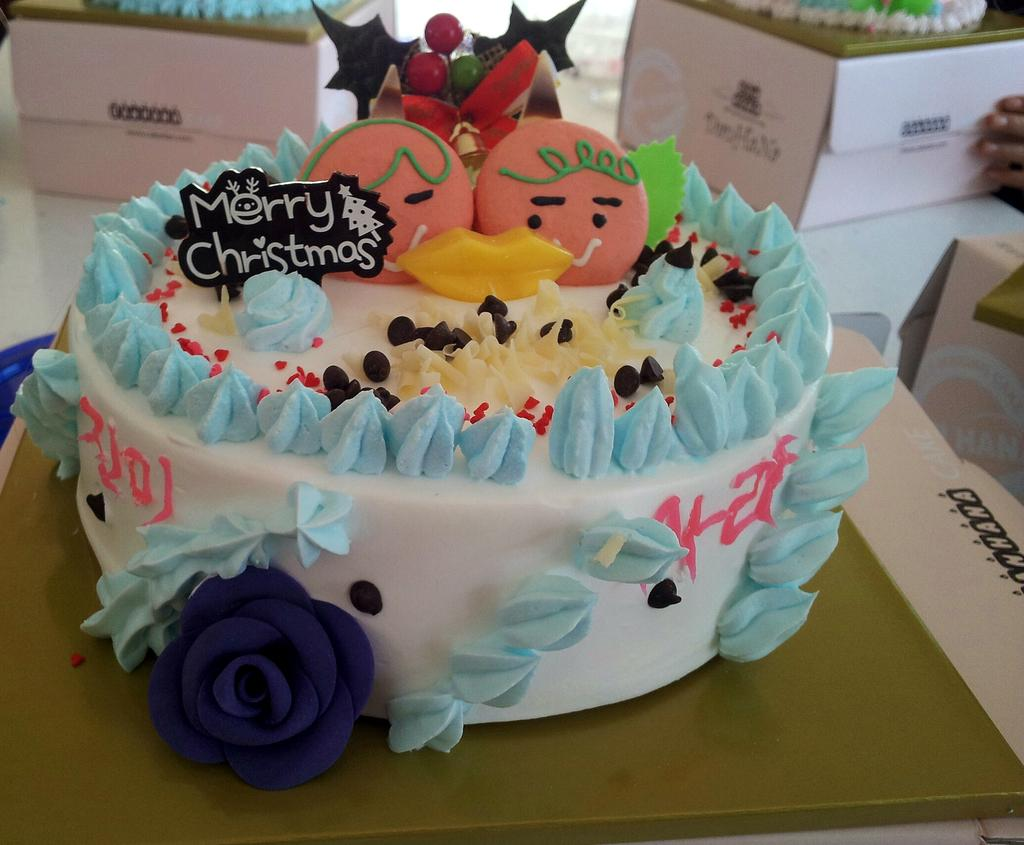What is the main subject of the image? There is a cake in the image. What colors can be seen on the cake? The cake has white, blue, red, and black colors. Where is the cake located in the image? The cake is placed on a table. What else can be seen in the background of the image? There are two white color boxes in the background of the image. How does the yak help in the preparation of the cake in the image? There is no yak present in the image, and therefore it cannot help in the preparation of the cake. 